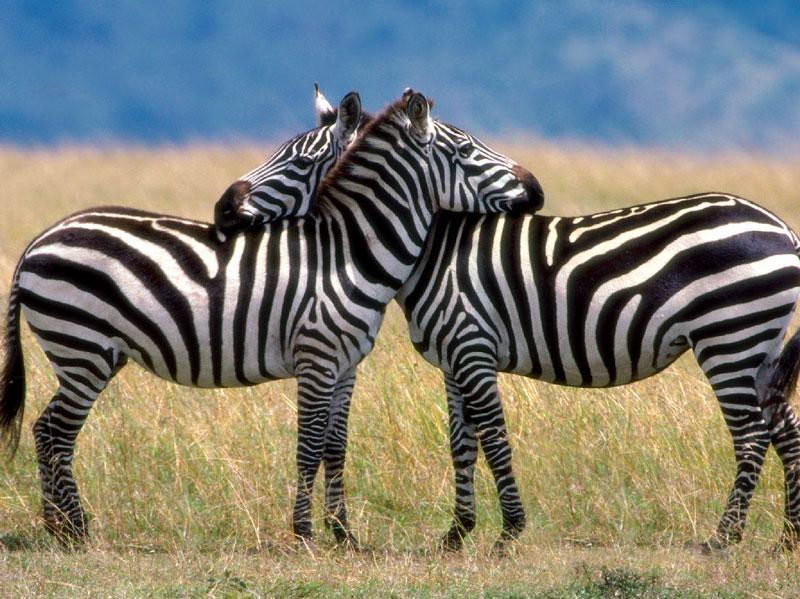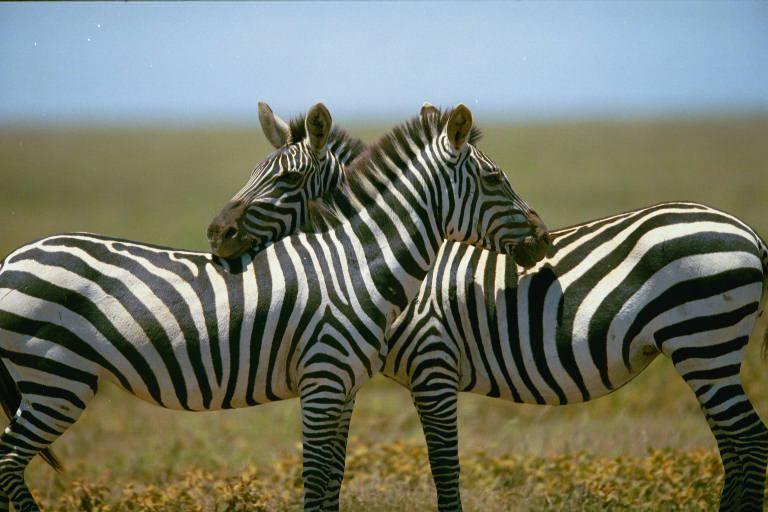The first image is the image on the left, the second image is the image on the right. Evaluate the accuracy of this statement regarding the images: "There are two zebras with there noses on the arch of the other zebras back.". Is it true? Answer yes or no. Yes. The first image is the image on the left, the second image is the image on the right. Examine the images to the left and right. Is the description "The left image shows a right-turned zebra standing closest to the camera, with its head resting on the shoulders of a left-turned zebra, and the left-turned zebra with its head resting on the shoulders of the right-turned zebra." accurate? Answer yes or no. Yes. 